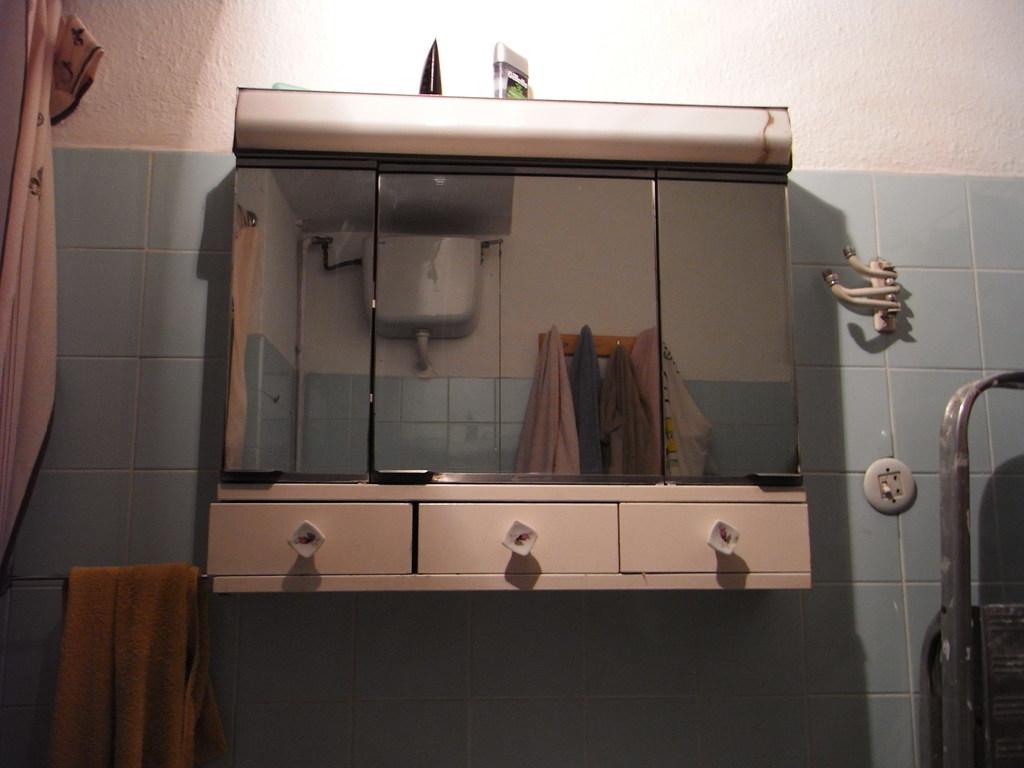Can you describe this image briefly? In this image there is a napkin on the iron rod, mirror and a cupboard with three drawers attached to the wall, there is a reflection of clothes hanged to the clothes hanger, flush tank. 